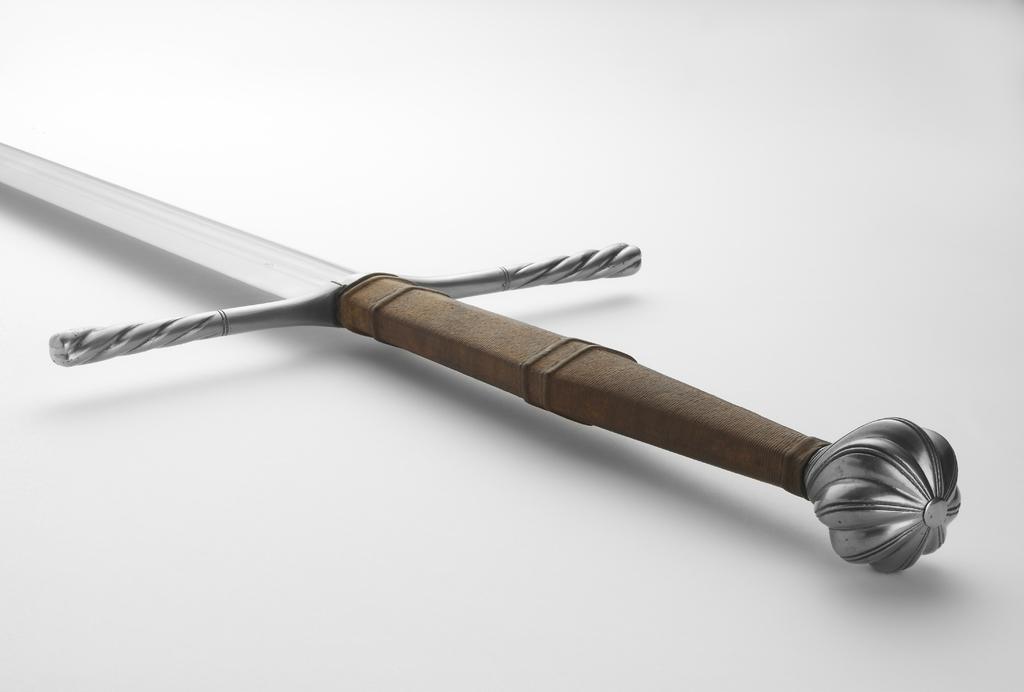How would you summarize this image in a sentence or two? In this picture there is a sword which has a brown handle to it is placed on a white surface. 